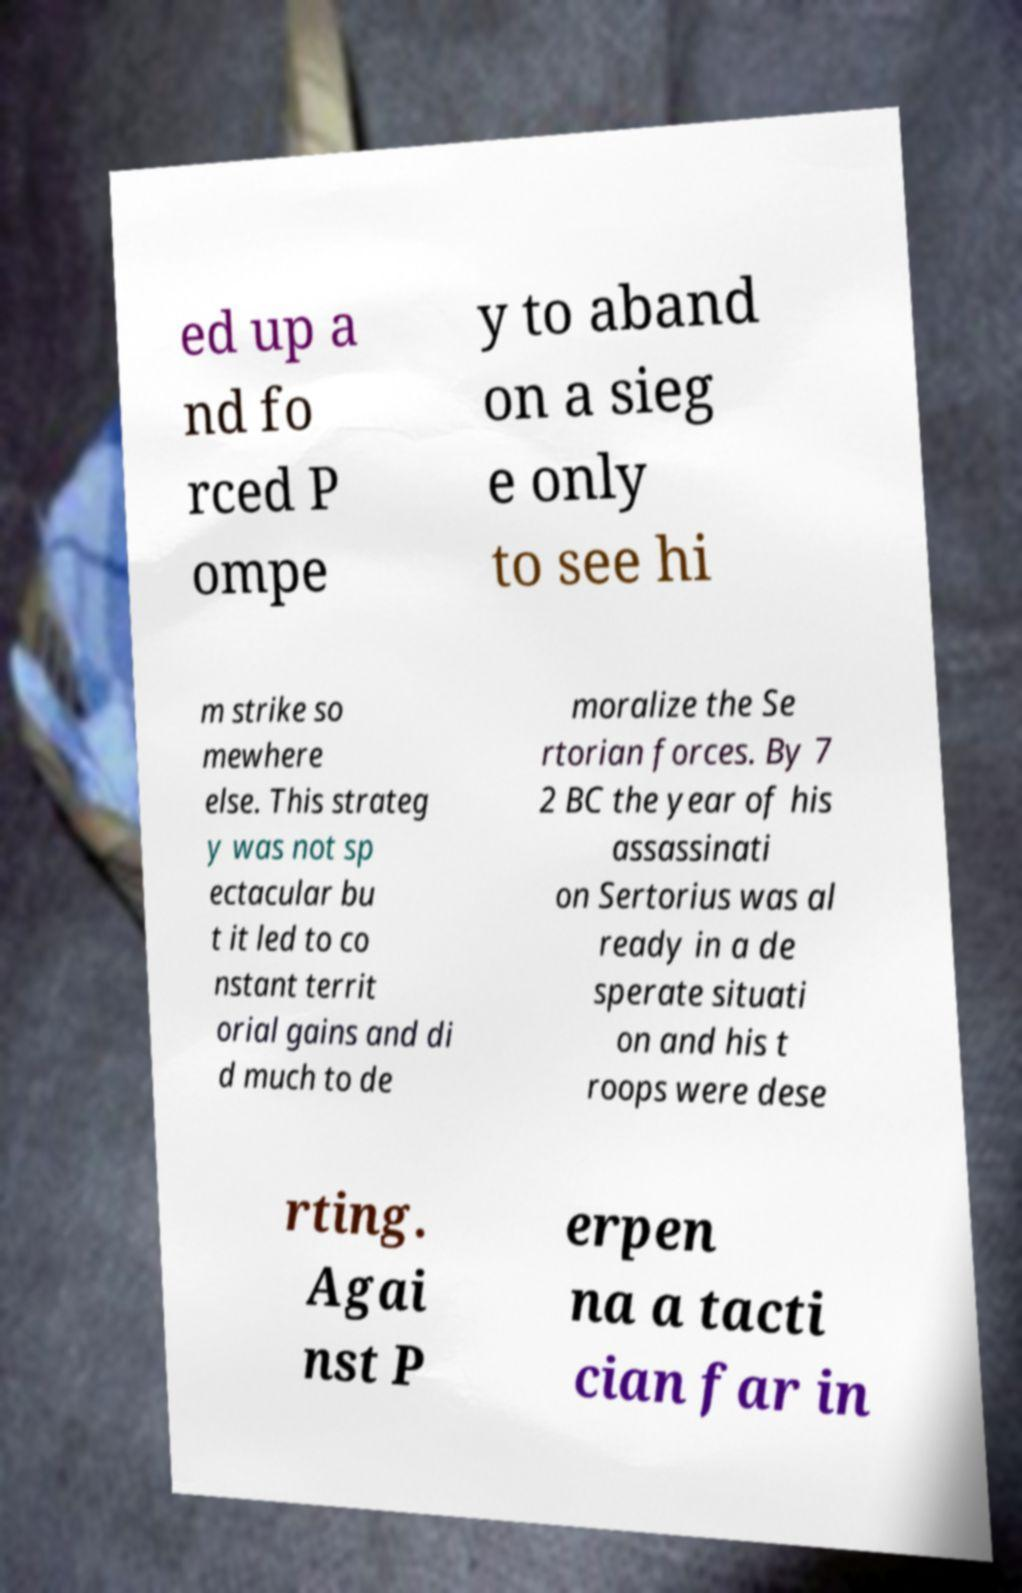What messages or text are displayed in this image? I need them in a readable, typed format. ed up a nd fo rced P ompe y to aband on a sieg e only to see hi m strike so mewhere else. This strateg y was not sp ectacular bu t it led to co nstant territ orial gains and di d much to de moralize the Se rtorian forces. By 7 2 BC the year of his assassinati on Sertorius was al ready in a de sperate situati on and his t roops were dese rting. Agai nst P erpen na a tacti cian far in 